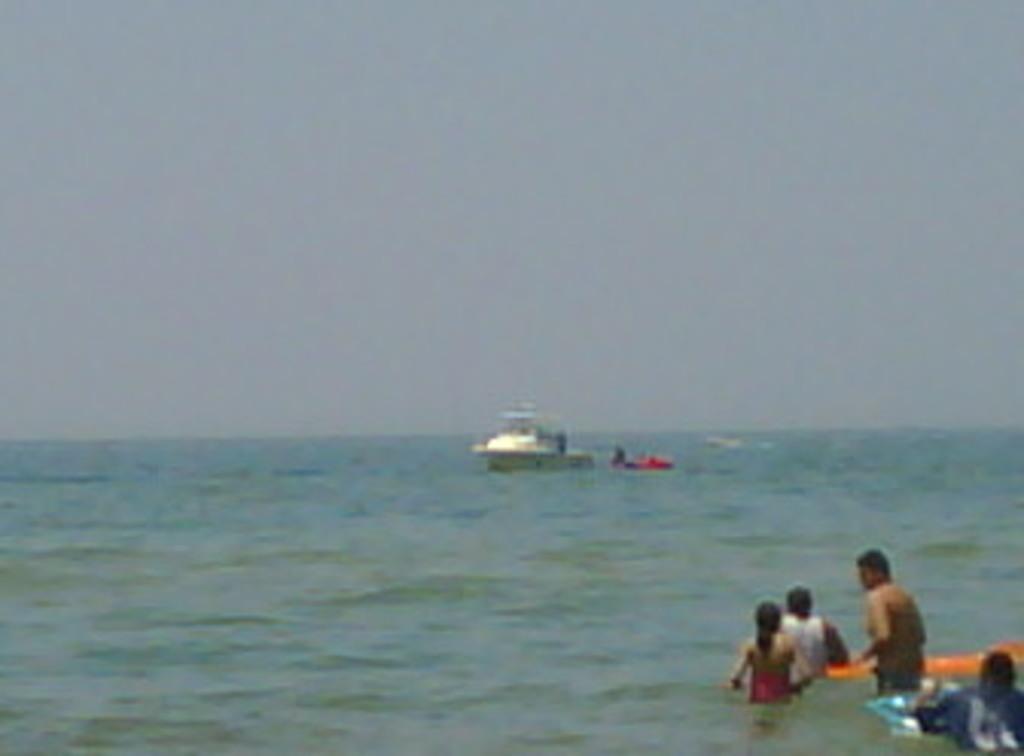Please provide a concise description of this image. In this image there is a motor boat on the water, and there are a few other people standing in the water. 